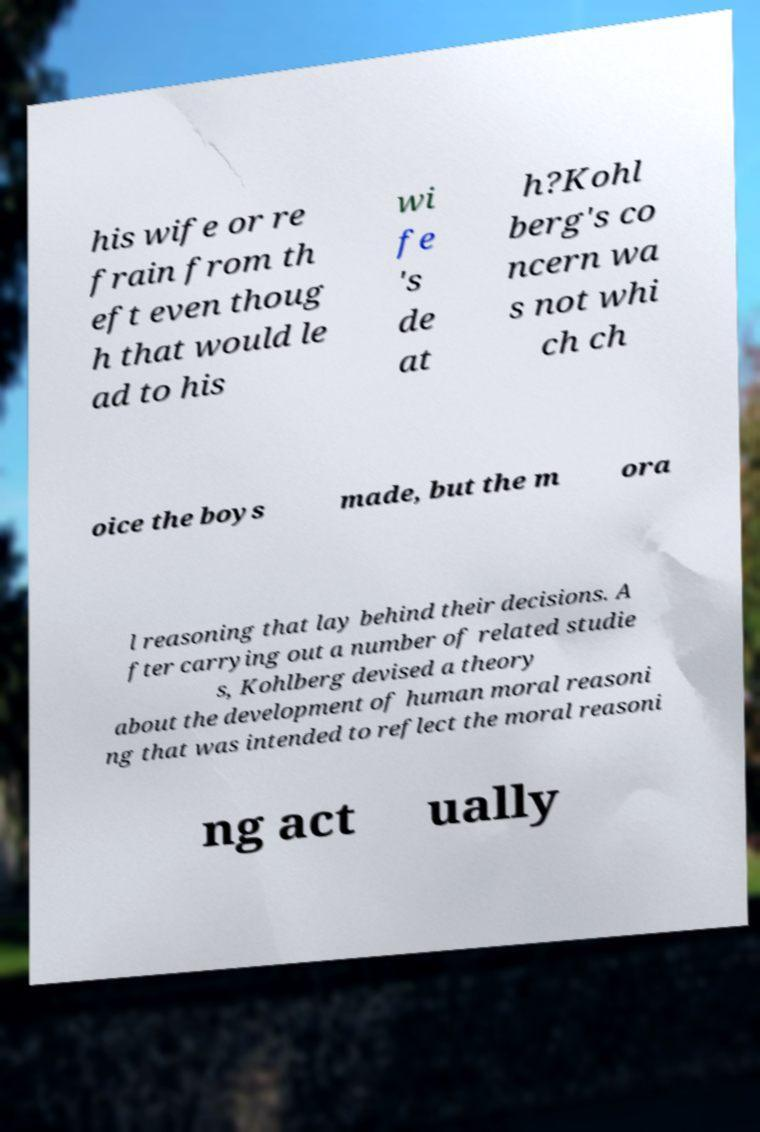Please read and relay the text visible in this image. What does it say? his wife or re frain from th eft even thoug h that would le ad to his wi fe 's de at h?Kohl berg's co ncern wa s not whi ch ch oice the boys made, but the m ora l reasoning that lay behind their decisions. A fter carrying out a number of related studie s, Kohlberg devised a theory about the development of human moral reasoni ng that was intended to reflect the moral reasoni ng act ually 